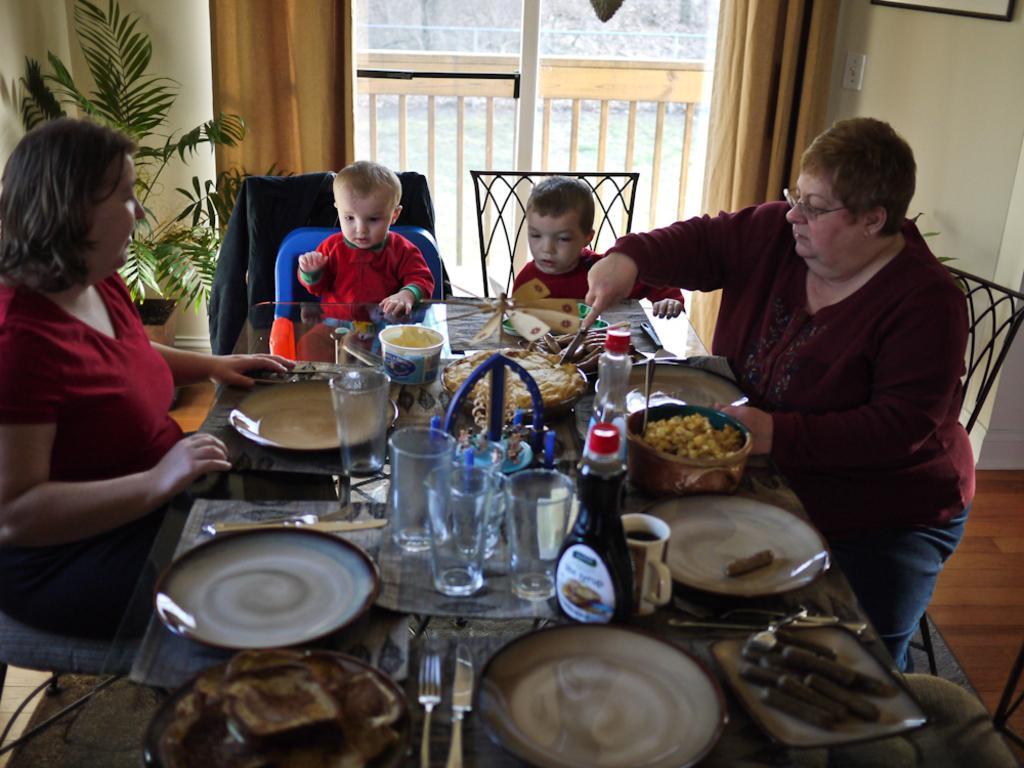Can you describe this image briefly? In this image I can see two women sitting on a chairs. There are two kids sitting. This is a table. There are many objects placed on it. I can see a plate,knife,fork,tumbler,boxes,bowls,bottles,Cup and some other food items were placed on the table. this is a chair. at background I can see a window which is closed and there are curtains hanging to the hanger,and at the left corner of the image on the background I can see a house plant. 